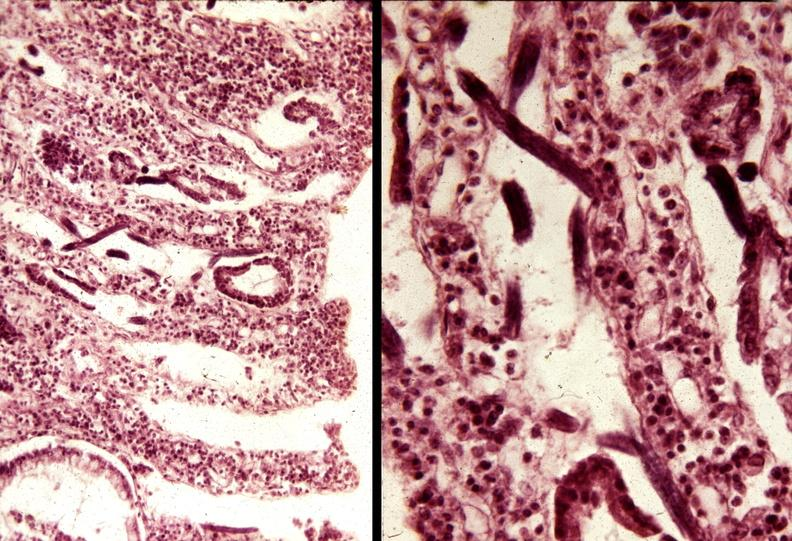what is present?
Answer the question using a single word or phrase. Gastrointestinal 